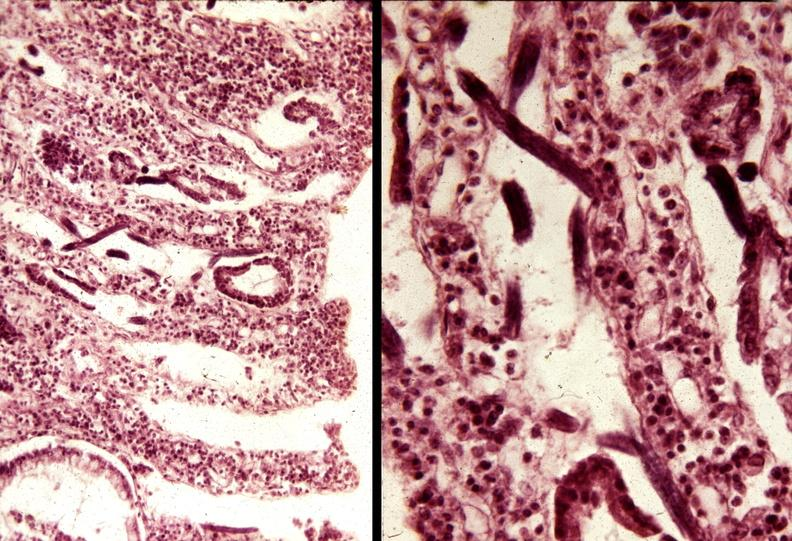what is present?
Answer the question using a single word or phrase. Gastrointestinal 